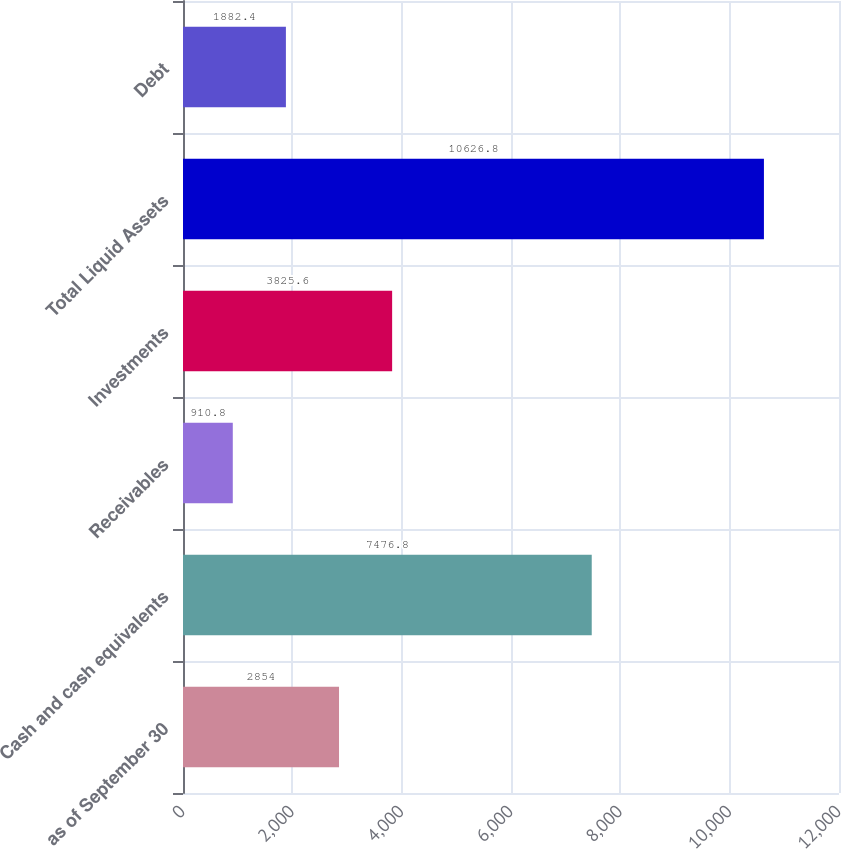<chart> <loc_0><loc_0><loc_500><loc_500><bar_chart><fcel>as of September 30<fcel>Cash and cash equivalents<fcel>Receivables<fcel>Investments<fcel>Total Liquid Assets<fcel>Debt<nl><fcel>2854<fcel>7476.8<fcel>910.8<fcel>3825.6<fcel>10626.8<fcel>1882.4<nl></chart> 